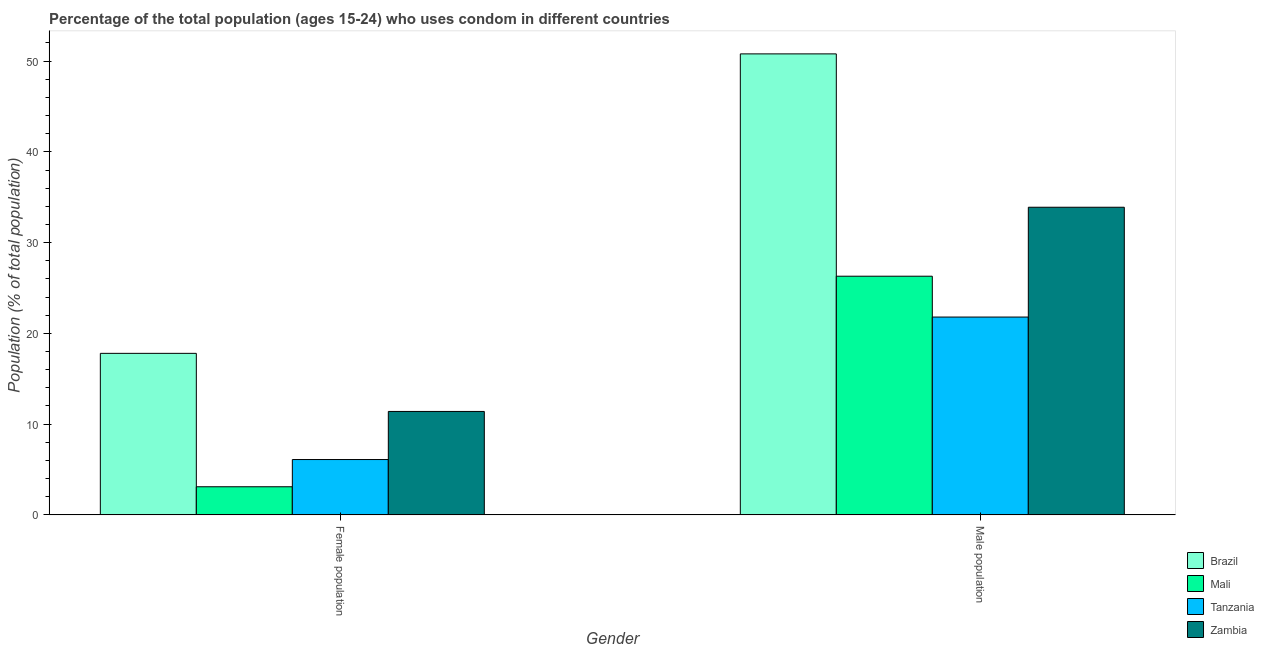Are the number of bars on each tick of the X-axis equal?
Provide a succinct answer. Yes. How many bars are there on the 2nd tick from the left?
Your answer should be very brief. 4. How many bars are there on the 2nd tick from the right?
Your answer should be very brief. 4. What is the label of the 1st group of bars from the left?
Your answer should be very brief. Female population. What is the male population in Tanzania?
Keep it short and to the point. 21.8. Across all countries, what is the maximum female population?
Give a very brief answer. 17.8. Across all countries, what is the minimum male population?
Provide a succinct answer. 21.8. In which country was the female population maximum?
Give a very brief answer. Brazil. In which country was the female population minimum?
Provide a succinct answer. Mali. What is the total male population in the graph?
Your response must be concise. 132.8. What is the difference between the female population in Brazil and that in Tanzania?
Your response must be concise. 11.7. What is the difference between the female population in Zambia and the male population in Brazil?
Ensure brevity in your answer.  -39.4. What is the average male population per country?
Your answer should be very brief. 33.2. What is the difference between the male population and female population in Tanzania?
Offer a terse response. 15.7. What is the ratio of the male population in Brazil to that in Zambia?
Offer a terse response. 1.5. Is the female population in Zambia less than that in Tanzania?
Offer a terse response. No. In how many countries, is the male population greater than the average male population taken over all countries?
Your answer should be compact. 2. What does the 4th bar from the left in Female population represents?
Your response must be concise. Zambia. What does the 3rd bar from the right in Female population represents?
Provide a short and direct response. Mali. How many bars are there?
Your response must be concise. 8. Are all the bars in the graph horizontal?
Offer a very short reply. No. How many countries are there in the graph?
Make the answer very short. 4. Are the values on the major ticks of Y-axis written in scientific E-notation?
Offer a terse response. No. Does the graph contain any zero values?
Your answer should be very brief. No. Does the graph contain grids?
Provide a succinct answer. No. What is the title of the graph?
Offer a terse response. Percentage of the total population (ages 15-24) who uses condom in different countries. What is the label or title of the Y-axis?
Offer a terse response. Population (% of total population) . What is the Population (% of total population)  of Brazil in Female population?
Provide a short and direct response. 17.8. What is the Population (% of total population)  in Mali in Female population?
Provide a succinct answer. 3.1. What is the Population (% of total population)  in Tanzania in Female population?
Your answer should be very brief. 6.1. What is the Population (% of total population)  in Zambia in Female population?
Your answer should be very brief. 11.4. What is the Population (% of total population)  in Brazil in Male population?
Provide a succinct answer. 50.8. What is the Population (% of total population)  in Mali in Male population?
Keep it short and to the point. 26.3. What is the Population (% of total population)  of Tanzania in Male population?
Your answer should be compact. 21.8. What is the Population (% of total population)  of Zambia in Male population?
Your response must be concise. 33.9. Across all Gender, what is the maximum Population (% of total population)  in Brazil?
Your answer should be compact. 50.8. Across all Gender, what is the maximum Population (% of total population)  in Mali?
Keep it short and to the point. 26.3. Across all Gender, what is the maximum Population (% of total population)  in Tanzania?
Ensure brevity in your answer.  21.8. Across all Gender, what is the maximum Population (% of total population)  in Zambia?
Your answer should be very brief. 33.9. Across all Gender, what is the minimum Population (% of total population)  of Brazil?
Your answer should be compact. 17.8. Across all Gender, what is the minimum Population (% of total population)  in Zambia?
Give a very brief answer. 11.4. What is the total Population (% of total population)  of Brazil in the graph?
Keep it short and to the point. 68.6. What is the total Population (% of total population)  of Mali in the graph?
Ensure brevity in your answer.  29.4. What is the total Population (% of total population)  of Tanzania in the graph?
Ensure brevity in your answer.  27.9. What is the total Population (% of total population)  of Zambia in the graph?
Give a very brief answer. 45.3. What is the difference between the Population (% of total population)  in Brazil in Female population and that in Male population?
Ensure brevity in your answer.  -33. What is the difference between the Population (% of total population)  of Mali in Female population and that in Male population?
Provide a succinct answer. -23.2. What is the difference between the Population (% of total population)  in Tanzania in Female population and that in Male population?
Keep it short and to the point. -15.7. What is the difference between the Population (% of total population)  of Zambia in Female population and that in Male population?
Offer a terse response. -22.5. What is the difference between the Population (% of total population)  of Brazil in Female population and the Population (% of total population)  of Mali in Male population?
Your response must be concise. -8.5. What is the difference between the Population (% of total population)  of Brazil in Female population and the Population (% of total population)  of Zambia in Male population?
Your answer should be compact. -16.1. What is the difference between the Population (% of total population)  of Mali in Female population and the Population (% of total population)  of Tanzania in Male population?
Ensure brevity in your answer.  -18.7. What is the difference between the Population (% of total population)  of Mali in Female population and the Population (% of total population)  of Zambia in Male population?
Your answer should be very brief. -30.8. What is the difference between the Population (% of total population)  in Tanzania in Female population and the Population (% of total population)  in Zambia in Male population?
Keep it short and to the point. -27.8. What is the average Population (% of total population)  of Brazil per Gender?
Your answer should be very brief. 34.3. What is the average Population (% of total population)  in Tanzania per Gender?
Your answer should be compact. 13.95. What is the average Population (% of total population)  in Zambia per Gender?
Give a very brief answer. 22.65. What is the difference between the Population (% of total population)  of Brazil and Population (% of total population)  of Mali in Female population?
Give a very brief answer. 14.7. What is the difference between the Population (% of total population)  in Brazil and Population (% of total population)  in Tanzania in Female population?
Your response must be concise. 11.7. What is the difference between the Population (% of total population)  in Mali and Population (% of total population)  in Tanzania in Female population?
Keep it short and to the point. -3. What is the difference between the Population (% of total population)  of Tanzania and Population (% of total population)  of Zambia in Female population?
Provide a succinct answer. -5.3. What is the difference between the Population (% of total population)  in Brazil and Population (% of total population)  in Zambia in Male population?
Give a very brief answer. 16.9. What is the difference between the Population (% of total population)  in Mali and Population (% of total population)  in Tanzania in Male population?
Keep it short and to the point. 4.5. What is the difference between the Population (% of total population)  of Mali and Population (% of total population)  of Zambia in Male population?
Your answer should be very brief. -7.6. What is the difference between the Population (% of total population)  in Tanzania and Population (% of total population)  in Zambia in Male population?
Your answer should be compact. -12.1. What is the ratio of the Population (% of total population)  of Brazil in Female population to that in Male population?
Your answer should be compact. 0.35. What is the ratio of the Population (% of total population)  in Mali in Female population to that in Male population?
Provide a succinct answer. 0.12. What is the ratio of the Population (% of total population)  in Tanzania in Female population to that in Male population?
Offer a terse response. 0.28. What is the ratio of the Population (% of total population)  in Zambia in Female population to that in Male population?
Your answer should be very brief. 0.34. What is the difference between the highest and the second highest Population (% of total population)  of Mali?
Your answer should be compact. 23.2. What is the difference between the highest and the second highest Population (% of total population)  in Tanzania?
Keep it short and to the point. 15.7. What is the difference between the highest and the second highest Population (% of total population)  in Zambia?
Your answer should be compact. 22.5. What is the difference between the highest and the lowest Population (% of total population)  of Mali?
Make the answer very short. 23.2. What is the difference between the highest and the lowest Population (% of total population)  of Zambia?
Offer a very short reply. 22.5. 